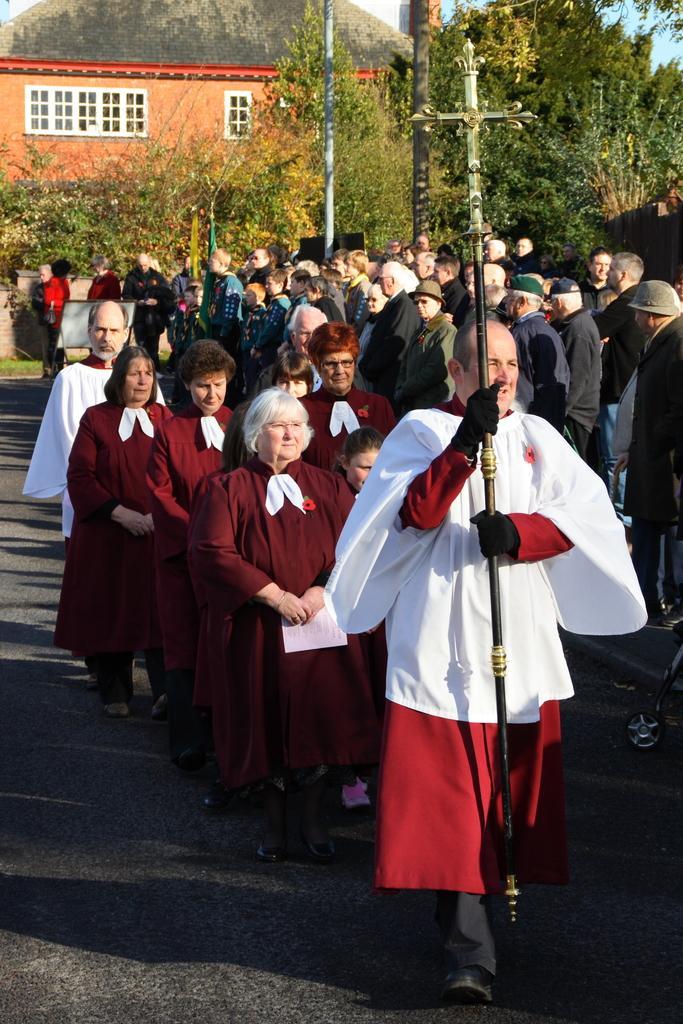Could you give a brief overview of what you see in this image? In the image there are a lot of people on the road and in the front the priest is carrying the Christ cross and behind them there are many trees. 